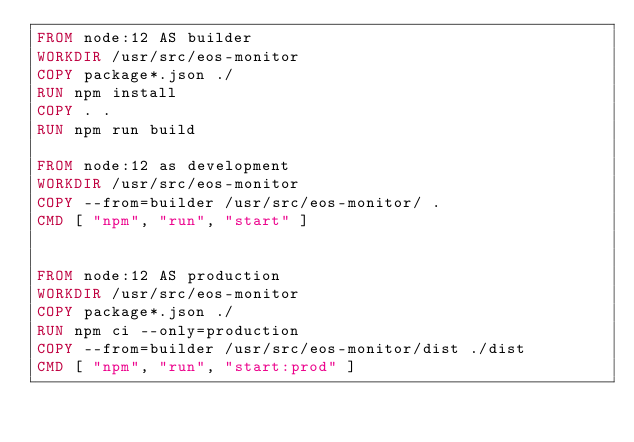Convert code to text. <code><loc_0><loc_0><loc_500><loc_500><_Dockerfile_>FROM node:12 AS builder
WORKDIR /usr/src/eos-monitor
COPY package*.json ./
RUN npm install
COPY . .
RUN npm run build

FROM node:12 as development
WORKDIR /usr/src/eos-monitor
COPY --from=builder /usr/src/eos-monitor/ .
CMD [ "npm", "run", "start" ]


FROM node:12 AS production
WORKDIR /usr/src/eos-monitor
COPY package*.json ./
RUN npm ci --only=production
COPY --from=builder /usr/src/eos-monitor/dist ./dist
CMD [ "npm", "run", "start:prod" ]</code> 